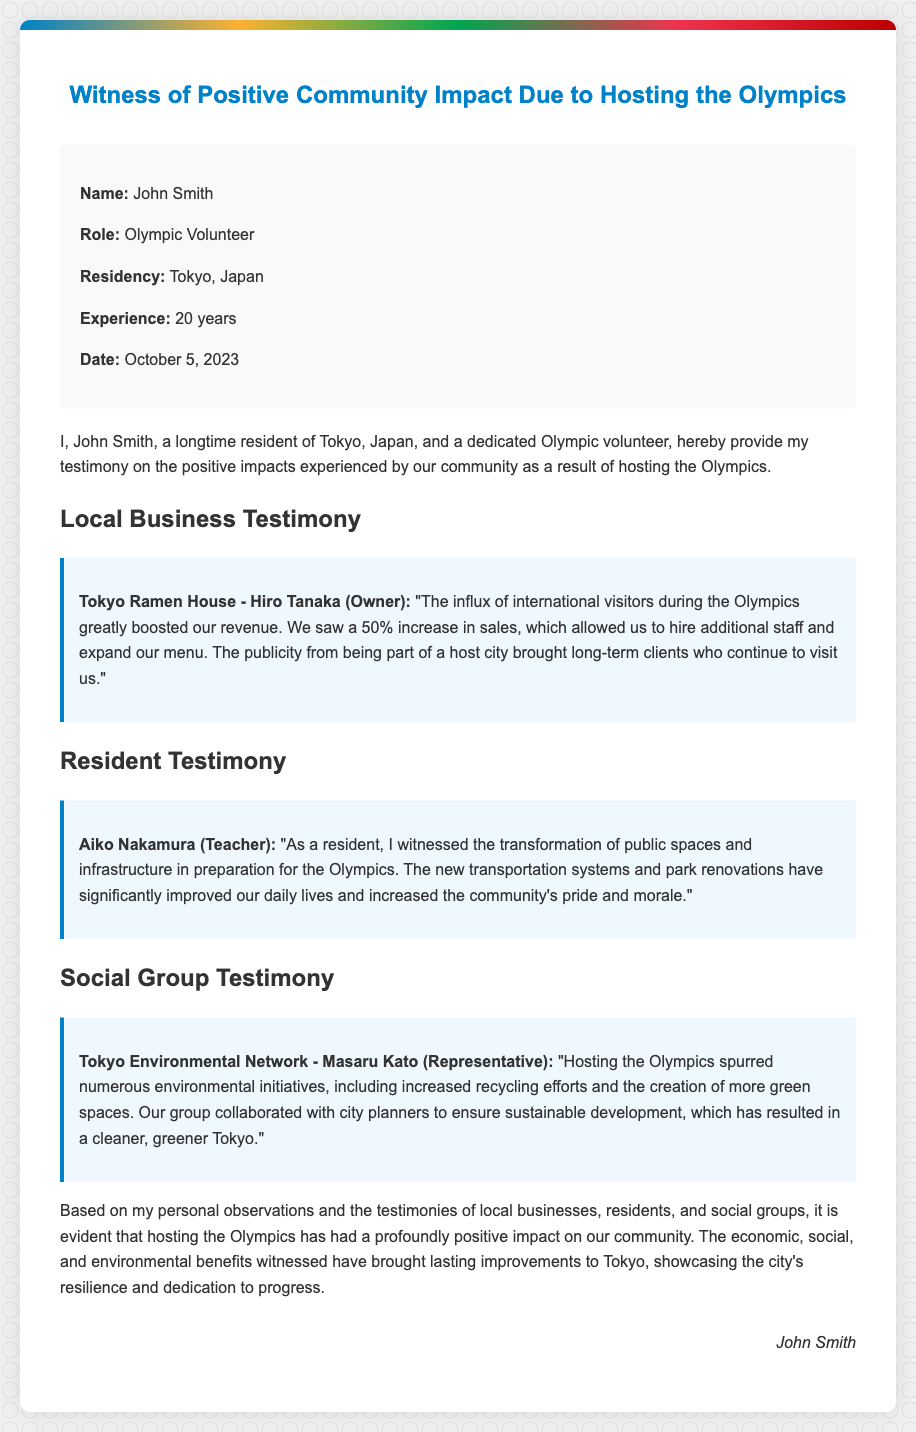What is the name of the affiant? The affiant's name is provided at the beginning of the document.
Answer: John Smith What is the role of the affiant? The role of the affiant is mentioned in the affiant details section.
Answer: Olympic Volunteer Which restaurant reported a 50% increase in sales? The restaurant's testimony is included under local business testimony.
Answer: Tokyo Ramen House Who is the owner of Tokyo Ramen House? The owner's name is specified in the local business testimony section.
Answer: Hiro Tanaka What significant change did Aiko Nakamura notice in her community? The testimony from Aiko Nakamura highlights a specific community improvement.
Answer: Transformation of public spaces and infrastructure What type of environmental initiatives were spurred by hosting the Olympics? The environmental initiatives mentioned encompass specific actions taken by the social group.
Answer: Increased recycling efforts and creation of green spaces What date is the affidavit signed? The date is explicitly stated in the affiant details.
Answer: October 5, 2023 Who provided testimony on behalf of the Tokyo Environmental Network? The representative’s name is mentioned in the social group testimony.
Answer: Masaru Kato What economic impact did the Olympics have on the local businesses according to the affidavit? The economic impact is inferred from the testimonies of local businesses.
Answer: Boosted revenue What is the primary theme of the affidavit? The overall message of the document can be summarized in one concept.
Answer: Positive community impact 